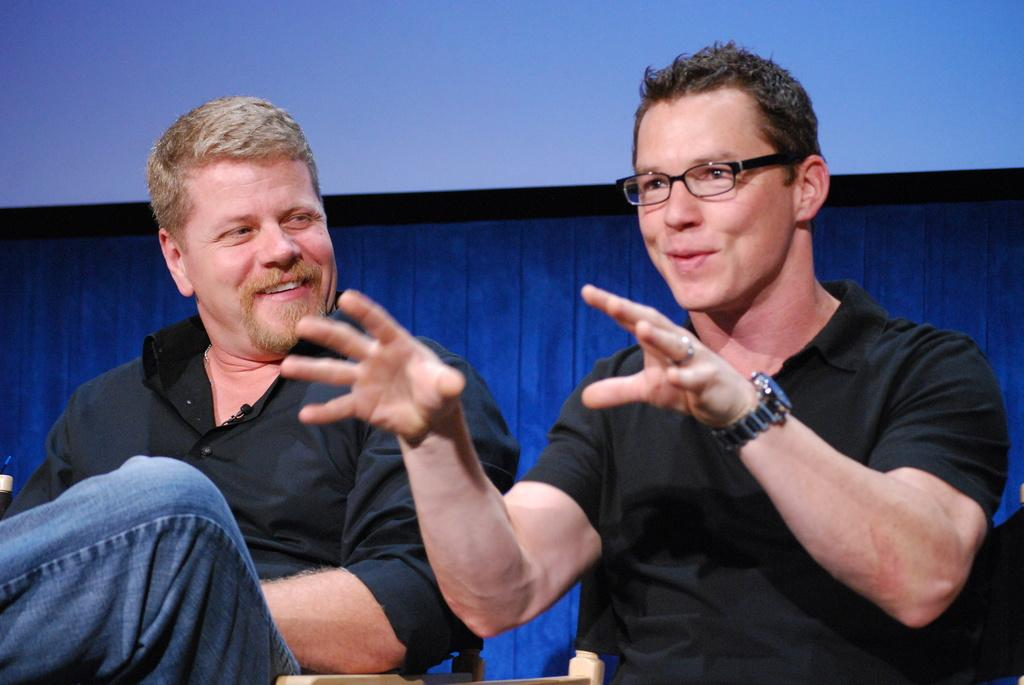How many people are in the image? There are two persons in the center of the image. What are the people doing in the image? One person is smiling, and the other person is talking. What can be seen in the background of the image? There is a wall in the background of the image, and a curtain is associated with the wall. What type of cushion can be seen on the wall in the image? There is no cushion present on the wall in the image. What songs are being sung by the person talking in the image? The image does not provide any information about the person talking singing songs. 